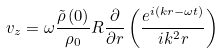<formula> <loc_0><loc_0><loc_500><loc_500>v _ { z } = \omega \frac { \tilde { \rho } \left ( 0 \right ) } { \rho _ { 0 } } R \frac { \partial } { \partial r } \left ( \frac { e ^ { i \left ( k r - \omega t \right ) } } { i k ^ { 2 } r } \right )</formula> 